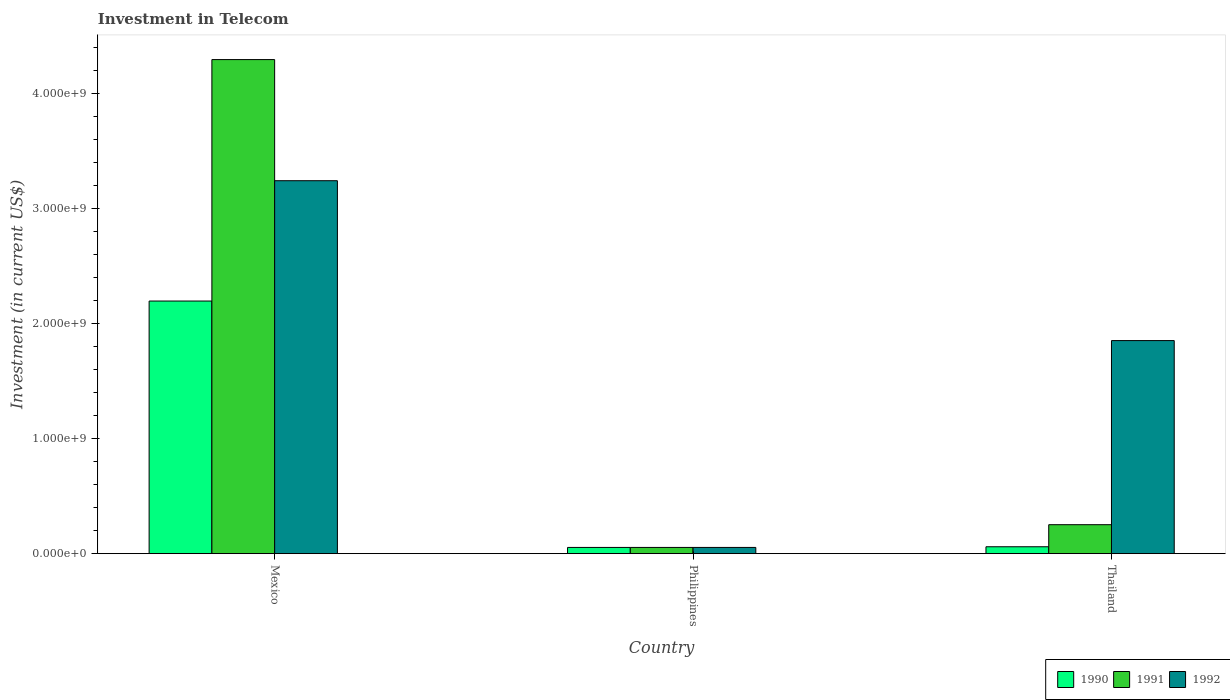How many different coloured bars are there?
Ensure brevity in your answer.  3. Are the number of bars per tick equal to the number of legend labels?
Provide a short and direct response. Yes. What is the label of the 1st group of bars from the left?
Offer a very short reply. Mexico. In how many cases, is the number of bars for a given country not equal to the number of legend labels?
Ensure brevity in your answer.  0. What is the amount invested in telecom in 1992 in Thailand?
Your answer should be very brief. 1.85e+09. Across all countries, what is the maximum amount invested in telecom in 1992?
Your response must be concise. 3.24e+09. Across all countries, what is the minimum amount invested in telecom in 1990?
Your response must be concise. 5.42e+07. In which country was the amount invested in telecom in 1992 minimum?
Give a very brief answer. Philippines. What is the total amount invested in telecom in 1990 in the graph?
Your response must be concise. 2.31e+09. What is the difference between the amount invested in telecom in 1991 in Philippines and that in Thailand?
Your answer should be compact. -1.98e+08. What is the difference between the amount invested in telecom in 1990 in Philippines and the amount invested in telecom in 1991 in Thailand?
Your answer should be very brief. -1.98e+08. What is the average amount invested in telecom in 1990 per country?
Your answer should be compact. 7.71e+08. In how many countries, is the amount invested in telecom in 1990 greater than 3000000000 US$?
Your response must be concise. 0. What is the ratio of the amount invested in telecom in 1992 in Philippines to that in Thailand?
Keep it short and to the point. 0.03. Is the amount invested in telecom in 1990 in Philippines less than that in Thailand?
Provide a succinct answer. Yes. Is the difference between the amount invested in telecom in 1991 in Mexico and Thailand greater than the difference between the amount invested in telecom in 1990 in Mexico and Thailand?
Your answer should be compact. Yes. What is the difference between the highest and the second highest amount invested in telecom in 1991?
Provide a succinct answer. 4.05e+09. What is the difference between the highest and the lowest amount invested in telecom in 1992?
Give a very brief answer. 3.19e+09. In how many countries, is the amount invested in telecom in 1990 greater than the average amount invested in telecom in 1990 taken over all countries?
Your answer should be compact. 1. Is it the case that in every country, the sum of the amount invested in telecom in 1991 and amount invested in telecom in 1992 is greater than the amount invested in telecom in 1990?
Keep it short and to the point. Yes. How many bars are there?
Your response must be concise. 9. Does the graph contain grids?
Provide a succinct answer. No. Where does the legend appear in the graph?
Your answer should be very brief. Bottom right. How many legend labels are there?
Your response must be concise. 3. What is the title of the graph?
Make the answer very short. Investment in Telecom. Does "1985" appear as one of the legend labels in the graph?
Your answer should be very brief. No. What is the label or title of the X-axis?
Offer a terse response. Country. What is the label or title of the Y-axis?
Give a very brief answer. Investment (in current US$). What is the Investment (in current US$) of 1990 in Mexico?
Provide a succinct answer. 2.20e+09. What is the Investment (in current US$) of 1991 in Mexico?
Give a very brief answer. 4.30e+09. What is the Investment (in current US$) in 1992 in Mexico?
Your answer should be very brief. 3.24e+09. What is the Investment (in current US$) of 1990 in Philippines?
Provide a succinct answer. 5.42e+07. What is the Investment (in current US$) of 1991 in Philippines?
Provide a succinct answer. 5.42e+07. What is the Investment (in current US$) in 1992 in Philippines?
Offer a terse response. 5.42e+07. What is the Investment (in current US$) of 1990 in Thailand?
Give a very brief answer. 6.00e+07. What is the Investment (in current US$) of 1991 in Thailand?
Provide a succinct answer. 2.52e+08. What is the Investment (in current US$) in 1992 in Thailand?
Provide a short and direct response. 1.85e+09. Across all countries, what is the maximum Investment (in current US$) in 1990?
Give a very brief answer. 2.20e+09. Across all countries, what is the maximum Investment (in current US$) of 1991?
Ensure brevity in your answer.  4.30e+09. Across all countries, what is the maximum Investment (in current US$) in 1992?
Ensure brevity in your answer.  3.24e+09. Across all countries, what is the minimum Investment (in current US$) in 1990?
Provide a succinct answer. 5.42e+07. Across all countries, what is the minimum Investment (in current US$) of 1991?
Offer a terse response. 5.42e+07. Across all countries, what is the minimum Investment (in current US$) in 1992?
Provide a succinct answer. 5.42e+07. What is the total Investment (in current US$) in 1990 in the graph?
Provide a short and direct response. 2.31e+09. What is the total Investment (in current US$) in 1991 in the graph?
Keep it short and to the point. 4.61e+09. What is the total Investment (in current US$) in 1992 in the graph?
Your response must be concise. 5.15e+09. What is the difference between the Investment (in current US$) in 1990 in Mexico and that in Philippines?
Ensure brevity in your answer.  2.14e+09. What is the difference between the Investment (in current US$) of 1991 in Mexico and that in Philippines?
Offer a very short reply. 4.24e+09. What is the difference between the Investment (in current US$) in 1992 in Mexico and that in Philippines?
Make the answer very short. 3.19e+09. What is the difference between the Investment (in current US$) of 1990 in Mexico and that in Thailand?
Keep it short and to the point. 2.14e+09. What is the difference between the Investment (in current US$) in 1991 in Mexico and that in Thailand?
Keep it short and to the point. 4.05e+09. What is the difference between the Investment (in current US$) of 1992 in Mexico and that in Thailand?
Offer a terse response. 1.39e+09. What is the difference between the Investment (in current US$) in 1990 in Philippines and that in Thailand?
Provide a succinct answer. -5.80e+06. What is the difference between the Investment (in current US$) of 1991 in Philippines and that in Thailand?
Your answer should be compact. -1.98e+08. What is the difference between the Investment (in current US$) of 1992 in Philippines and that in Thailand?
Ensure brevity in your answer.  -1.80e+09. What is the difference between the Investment (in current US$) of 1990 in Mexico and the Investment (in current US$) of 1991 in Philippines?
Offer a very short reply. 2.14e+09. What is the difference between the Investment (in current US$) in 1990 in Mexico and the Investment (in current US$) in 1992 in Philippines?
Ensure brevity in your answer.  2.14e+09. What is the difference between the Investment (in current US$) in 1991 in Mexico and the Investment (in current US$) in 1992 in Philippines?
Offer a very short reply. 4.24e+09. What is the difference between the Investment (in current US$) of 1990 in Mexico and the Investment (in current US$) of 1991 in Thailand?
Provide a succinct answer. 1.95e+09. What is the difference between the Investment (in current US$) of 1990 in Mexico and the Investment (in current US$) of 1992 in Thailand?
Provide a short and direct response. 3.44e+08. What is the difference between the Investment (in current US$) in 1991 in Mexico and the Investment (in current US$) in 1992 in Thailand?
Your answer should be very brief. 2.44e+09. What is the difference between the Investment (in current US$) in 1990 in Philippines and the Investment (in current US$) in 1991 in Thailand?
Keep it short and to the point. -1.98e+08. What is the difference between the Investment (in current US$) of 1990 in Philippines and the Investment (in current US$) of 1992 in Thailand?
Your response must be concise. -1.80e+09. What is the difference between the Investment (in current US$) of 1991 in Philippines and the Investment (in current US$) of 1992 in Thailand?
Your response must be concise. -1.80e+09. What is the average Investment (in current US$) of 1990 per country?
Offer a very short reply. 7.71e+08. What is the average Investment (in current US$) in 1991 per country?
Make the answer very short. 1.54e+09. What is the average Investment (in current US$) of 1992 per country?
Offer a very short reply. 1.72e+09. What is the difference between the Investment (in current US$) of 1990 and Investment (in current US$) of 1991 in Mexico?
Provide a short and direct response. -2.10e+09. What is the difference between the Investment (in current US$) of 1990 and Investment (in current US$) of 1992 in Mexico?
Keep it short and to the point. -1.05e+09. What is the difference between the Investment (in current US$) of 1991 and Investment (in current US$) of 1992 in Mexico?
Offer a terse response. 1.05e+09. What is the difference between the Investment (in current US$) of 1990 and Investment (in current US$) of 1991 in Philippines?
Your answer should be compact. 0. What is the difference between the Investment (in current US$) of 1990 and Investment (in current US$) of 1991 in Thailand?
Provide a short and direct response. -1.92e+08. What is the difference between the Investment (in current US$) of 1990 and Investment (in current US$) of 1992 in Thailand?
Ensure brevity in your answer.  -1.79e+09. What is the difference between the Investment (in current US$) in 1991 and Investment (in current US$) in 1992 in Thailand?
Make the answer very short. -1.60e+09. What is the ratio of the Investment (in current US$) in 1990 in Mexico to that in Philippines?
Give a very brief answer. 40.55. What is the ratio of the Investment (in current US$) of 1991 in Mexico to that in Philippines?
Your answer should be compact. 79.32. What is the ratio of the Investment (in current US$) in 1992 in Mexico to that in Philippines?
Your answer should be very brief. 59.87. What is the ratio of the Investment (in current US$) of 1990 in Mexico to that in Thailand?
Provide a short and direct response. 36.63. What is the ratio of the Investment (in current US$) in 1991 in Mexico to that in Thailand?
Your answer should be compact. 17.06. What is the ratio of the Investment (in current US$) in 1992 in Mexico to that in Thailand?
Provide a short and direct response. 1.75. What is the ratio of the Investment (in current US$) in 1990 in Philippines to that in Thailand?
Offer a very short reply. 0.9. What is the ratio of the Investment (in current US$) in 1991 in Philippines to that in Thailand?
Your answer should be very brief. 0.22. What is the ratio of the Investment (in current US$) of 1992 in Philippines to that in Thailand?
Make the answer very short. 0.03. What is the difference between the highest and the second highest Investment (in current US$) in 1990?
Your answer should be very brief. 2.14e+09. What is the difference between the highest and the second highest Investment (in current US$) of 1991?
Your answer should be compact. 4.05e+09. What is the difference between the highest and the second highest Investment (in current US$) in 1992?
Ensure brevity in your answer.  1.39e+09. What is the difference between the highest and the lowest Investment (in current US$) of 1990?
Provide a succinct answer. 2.14e+09. What is the difference between the highest and the lowest Investment (in current US$) of 1991?
Offer a terse response. 4.24e+09. What is the difference between the highest and the lowest Investment (in current US$) in 1992?
Keep it short and to the point. 3.19e+09. 